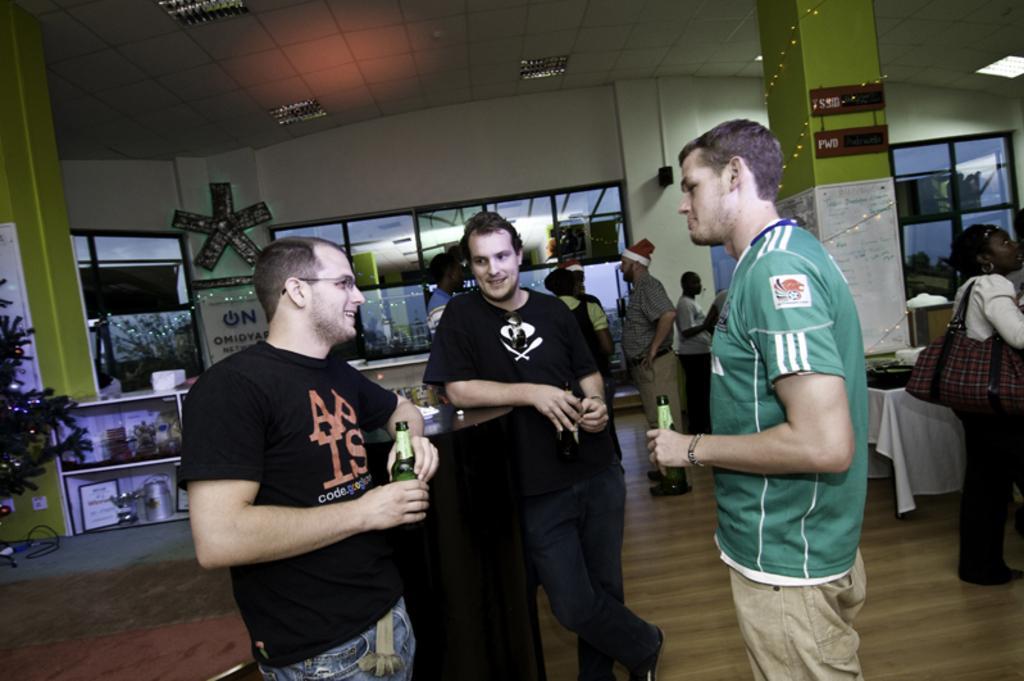Can you describe this image briefly? In this image there are people, inside a hall few are holding bottles in their hands, in between the people there is a table, in the background there are shops on top there is a ceiling and lights. 